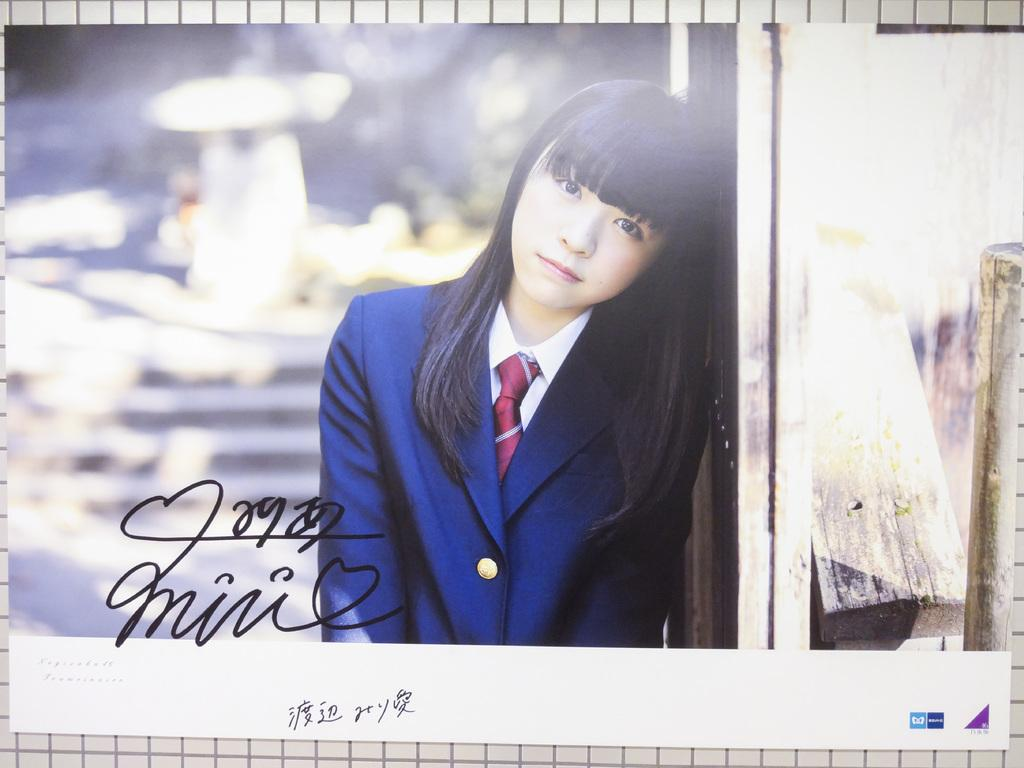What is present on the wall in the image? There is a poster on the wall in the image. What is depicted on the poster? The poster has a picture of a girl on it. Is there any text on the poster? Yes, there is text on the poster. What type of plantation can be seen in the background of the image? There is no plantation present in the image; it features a poster with a picture of a girl and text. 